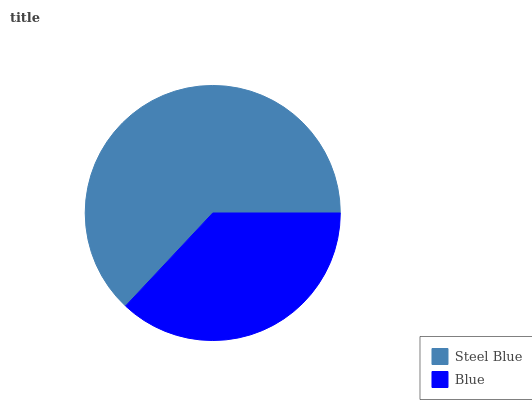Is Blue the minimum?
Answer yes or no. Yes. Is Steel Blue the maximum?
Answer yes or no. Yes. Is Blue the maximum?
Answer yes or no. No. Is Steel Blue greater than Blue?
Answer yes or no. Yes. Is Blue less than Steel Blue?
Answer yes or no. Yes. Is Blue greater than Steel Blue?
Answer yes or no. No. Is Steel Blue less than Blue?
Answer yes or no. No. Is Steel Blue the high median?
Answer yes or no. Yes. Is Blue the low median?
Answer yes or no. Yes. Is Blue the high median?
Answer yes or no. No. Is Steel Blue the low median?
Answer yes or no. No. 